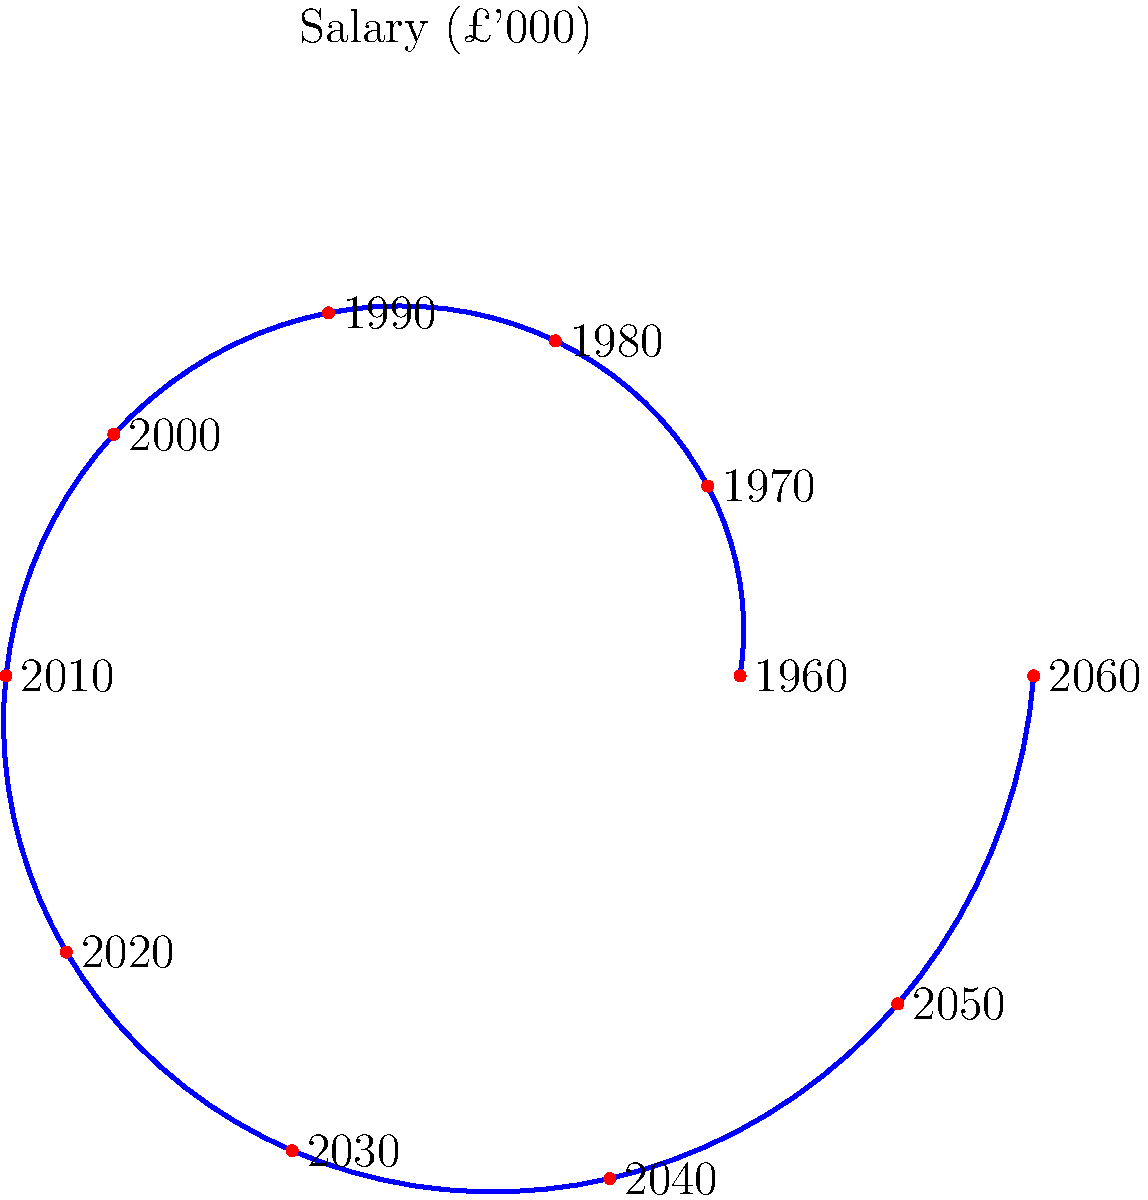In the spiral graph representing British civil servant salaries from 1960 to 2060, what is the approximate percentage increase in salary between 1960 and 2020? To calculate the percentage increase in salary between 1960 and 2020:

1. Identify the starting point (1960) and endpoint (2020) on the spiral.
2. Measure the radial distance from the center for both points.
3. Calculate the difference in radial distance.
4. Convert the difference to a percentage increase.

From the graph:
1. 1960 starting radius ≈ 5 units
2. 2020 radius ≈ 8 units
3. Difference: 8 - 5 = 3 units

Percentage increase:
$$ \text{Percentage increase} = \frac{\text{Increase}}{\text{Original}} \times 100\% $$
$$ = \frac{3}{5} \times 100\% = 60\% $$

Therefore, the approximate percentage increase in salary between 1960 and 2020 is 60%.
Answer: 60% 